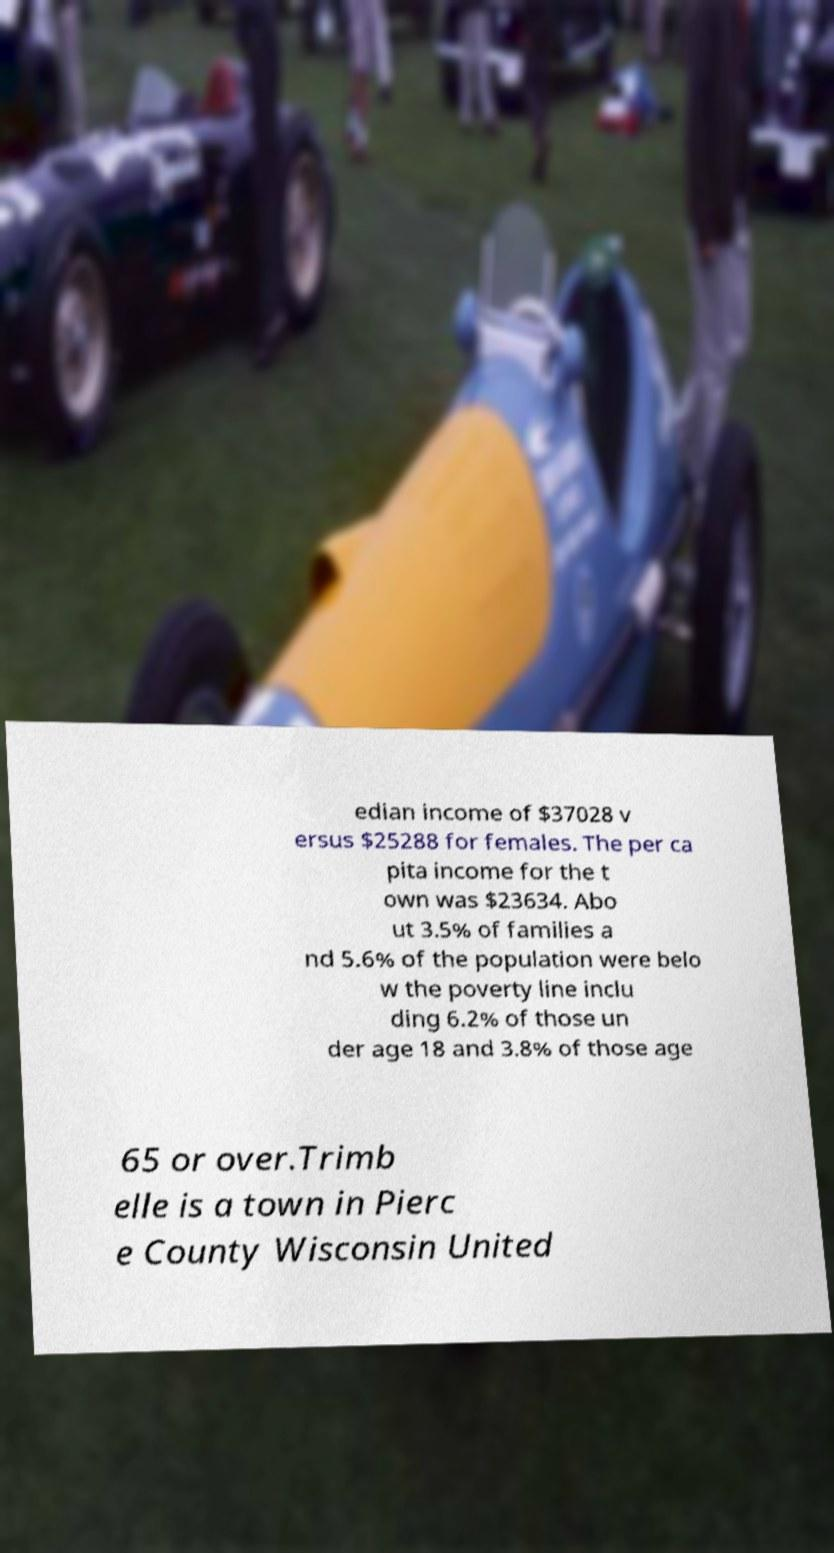Can you accurately transcribe the text from the provided image for me? edian income of $37028 v ersus $25288 for females. The per ca pita income for the t own was $23634. Abo ut 3.5% of families a nd 5.6% of the population were belo w the poverty line inclu ding 6.2% of those un der age 18 and 3.8% of those age 65 or over.Trimb elle is a town in Pierc e County Wisconsin United 